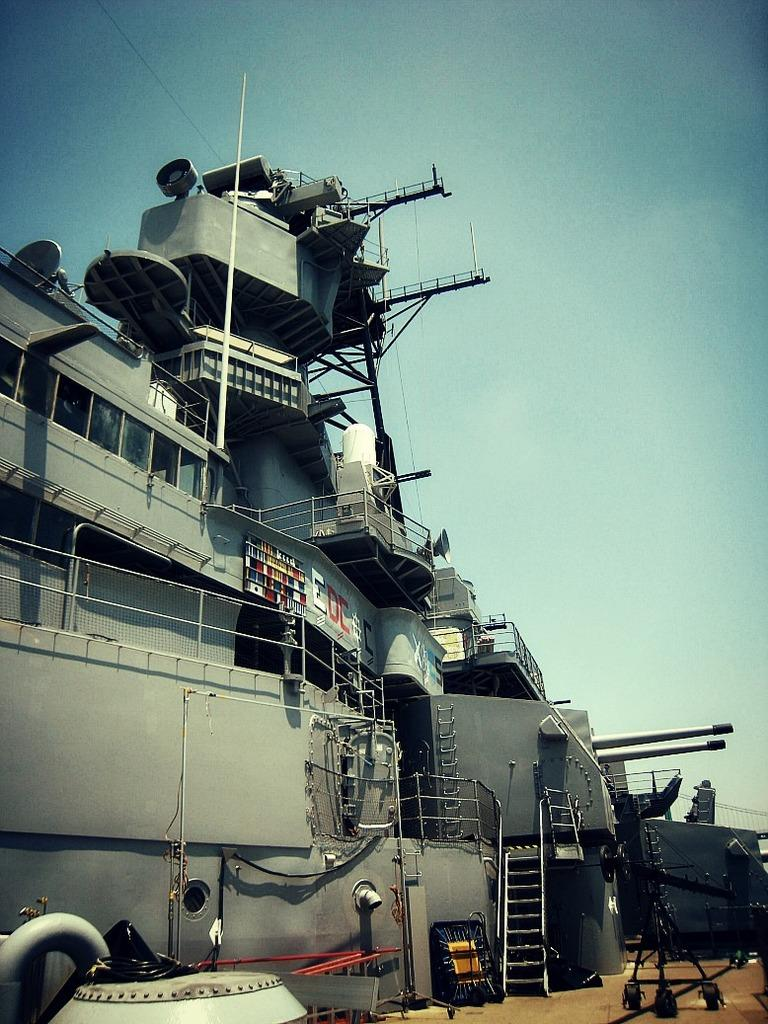What is the main subject of the image? There is a ship in the center of the image. What else can be seen in the image besides the ship? There are other objects in the background of the image. What is visible at the top of the image? The sky is visible at the top of the image. What type of shock can be seen affecting the ship in the image? There is no shock affecting the ship in the image; it appears to be stationary and undisturbed. 